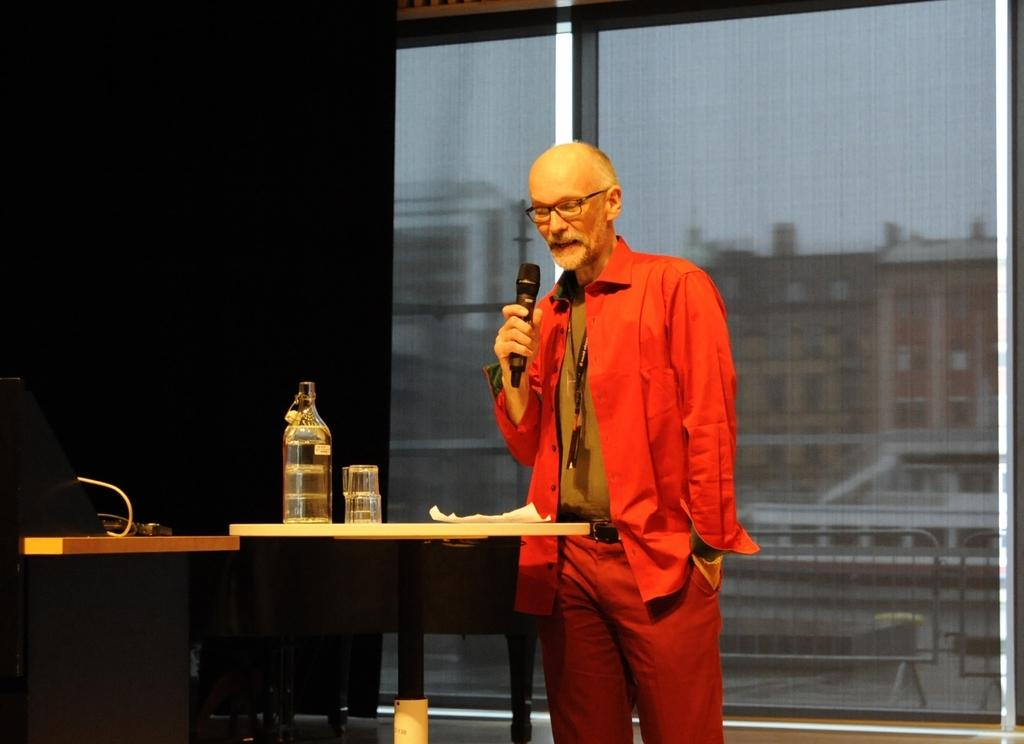Who is the main subject in the image? There is an old man in the image. What is the old man wearing? The old man is wearing a red suit and spectacles. What is the old man holding in the image? The old man is holding a mic. What can be seen on the screen in the image? Rain and buildings are visible on the screen. What is present on the table in the image? There is a bottle, glasses, and papers on the table. What type of pancake is being served on the table in the image? There is no pancake present on the table in the image. How does the old man maintain his balance while holding the mic in the image? The image does not show the old man's balance while holding the mic, as it is a still image. 